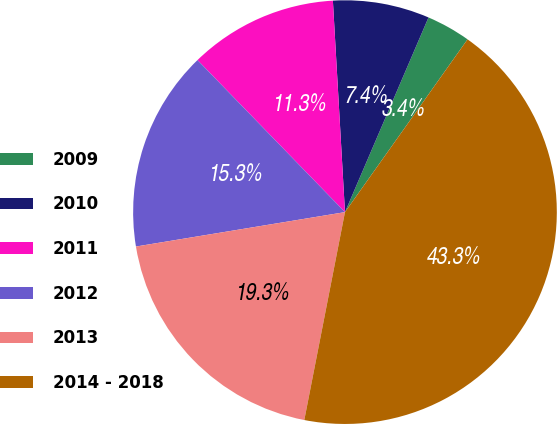<chart> <loc_0><loc_0><loc_500><loc_500><pie_chart><fcel>2009<fcel>2010<fcel>2011<fcel>2012<fcel>2013<fcel>2014 - 2018<nl><fcel>3.37%<fcel>7.36%<fcel>11.35%<fcel>15.34%<fcel>19.33%<fcel>43.26%<nl></chart> 